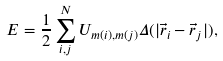<formula> <loc_0><loc_0><loc_500><loc_500>E = \frac { 1 } { 2 } \sum ^ { N } _ { i , j } U _ { m ( i ) , m ( j ) } \Delta ( | \vec { r } _ { i } - \vec { r } _ { j } | ) ,</formula> 